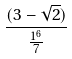Convert formula to latex. <formula><loc_0><loc_0><loc_500><loc_500>\frac { ( 3 - \sqrt { 2 } ) } { \frac { 1 ^ { 6 } } { 7 } }</formula> 